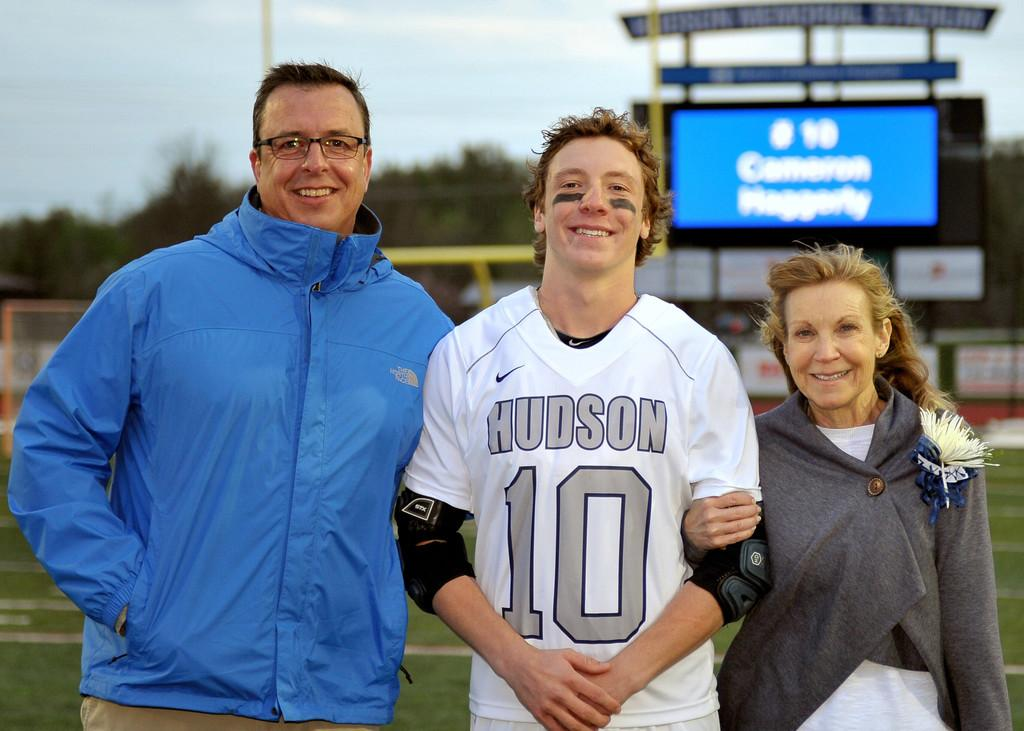<image>
Summarize the visual content of the image. A player from the Hudson football team poses with a man and a woman. 